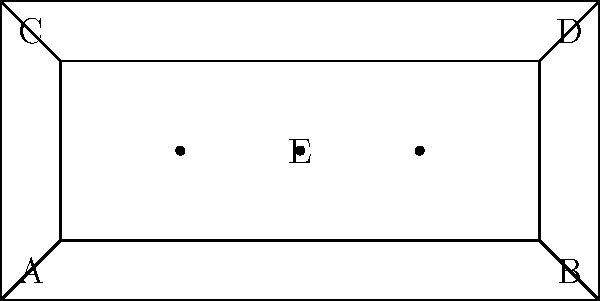In the stage layout diagram above, which represents a simplified concert setup, how many distinct paths can you trace from point A to point E without revisiting any point? This connectivity question is crucial for planning quick costume changes and stage movements during a performance. To solve this problem, let's break it down step-by-step:

1. Identify the possible paths:
   - Path 1: A → E (directly across the main stage)
   - Path 2: A → B → E
   - Path 3: A → C → E
   - Path 4: A → B → D → E
   - Path 5: A → C → D → E

2. Verify that these paths are distinct:
   - Each path uses a different combination of points
   - No path revisits any point

3. Check for any other possible paths:
   - There are no other ways to reach E from A without revisiting a point

4. Count the total number of distinct paths:
   - We have identified 5 distinct paths

5. Relevance to the persona:
   - Understanding stage connectivity is crucial for a singer to plan movements and costume changes efficiently during a performance, much like Selena would have done in her shows.

Therefore, there are 5 distinct paths from point A to point E in this stage layout.
Answer: 5 paths 